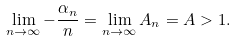<formula> <loc_0><loc_0><loc_500><loc_500>\lim _ { n \to \infty } - \frac { \alpha _ { n } } { n } = \lim _ { n \to \infty } A _ { n } = A > 1 .</formula> 